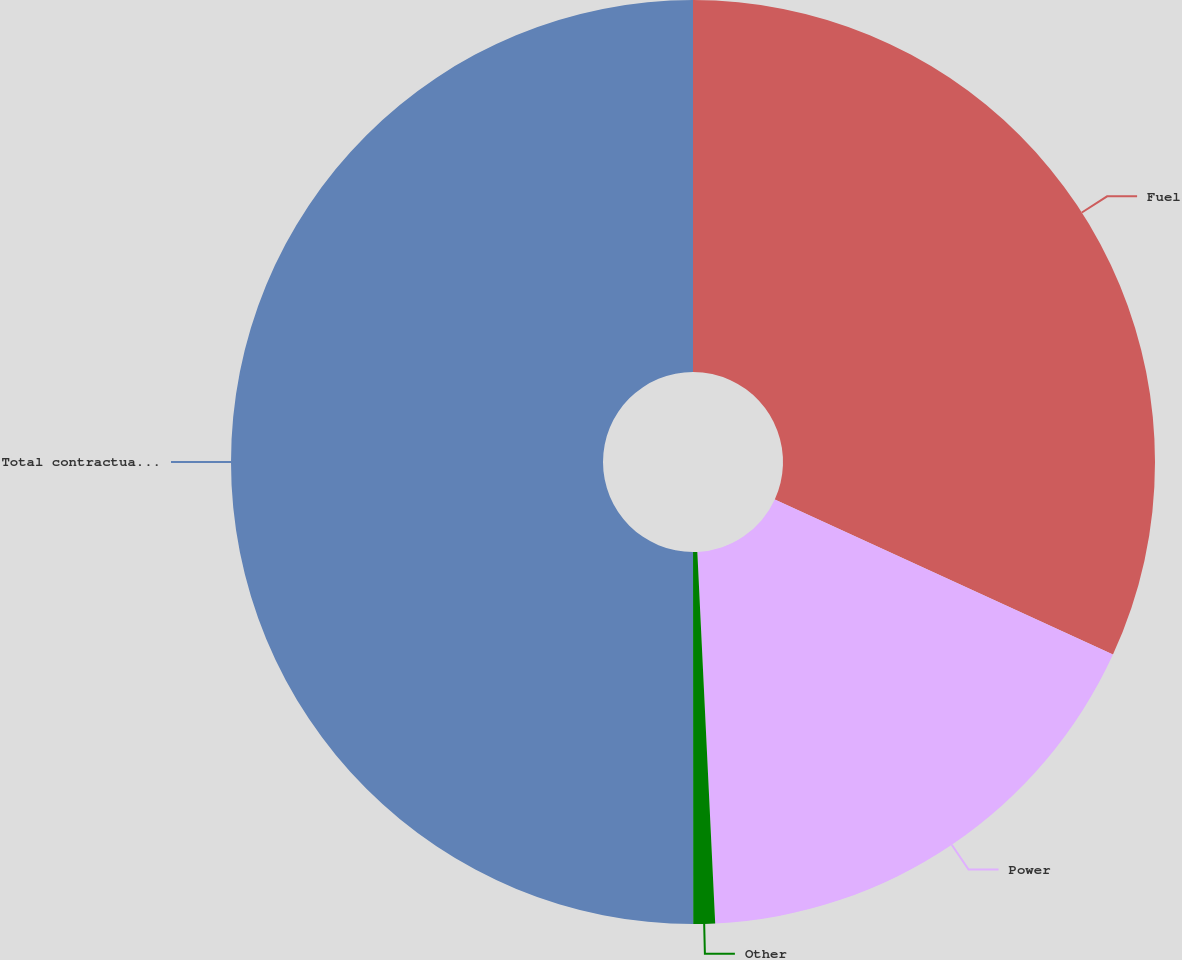Convert chart to OTSL. <chart><loc_0><loc_0><loc_500><loc_500><pie_chart><fcel>Fuel<fcel>Power<fcel>Other<fcel>Total contractual commitments<nl><fcel>31.84%<fcel>17.39%<fcel>0.76%<fcel>50.0%<nl></chart> 